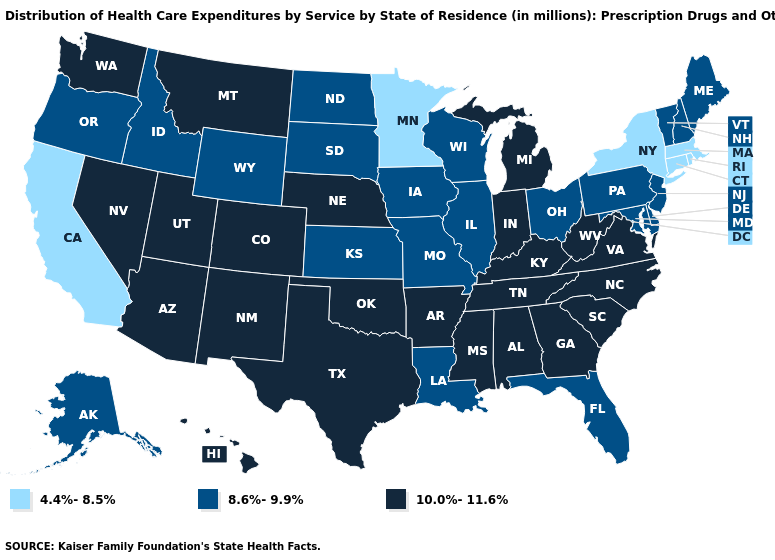What is the value of Alaska?
Keep it brief. 8.6%-9.9%. What is the value of Alaska?
Answer briefly. 8.6%-9.9%. What is the highest value in the USA?
Write a very short answer. 10.0%-11.6%. How many symbols are there in the legend?
Answer briefly. 3. Among the states that border Massachusetts , which have the highest value?
Be succinct. New Hampshire, Vermont. Name the states that have a value in the range 8.6%-9.9%?
Answer briefly. Alaska, Delaware, Florida, Idaho, Illinois, Iowa, Kansas, Louisiana, Maine, Maryland, Missouri, New Hampshire, New Jersey, North Dakota, Ohio, Oregon, Pennsylvania, South Dakota, Vermont, Wisconsin, Wyoming. Which states hav the highest value in the MidWest?
Give a very brief answer. Indiana, Michigan, Nebraska. Name the states that have a value in the range 10.0%-11.6%?
Answer briefly. Alabama, Arizona, Arkansas, Colorado, Georgia, Hawaii, Indiana, Kentucky, Michigan, Mississippi, Montana, Nebraska, Nevada, New Mexico, North Carolina, Oklahoma, South Carolina, Tennessee, Texas, Utah, Virginia, Washington, West Virginia. Does Louisiana have the highest value in the South?
Be succinct. No. What is the highest value in states that border Iowa?
Concise answer only. 10.0%-11.6%. Does Minnesota have the lowest value in the USA?
Short answer required. Yes. Does Arkansas have a lower value than Montana?
Give a very brief answer. No. What is the value of Vermont?
Give a very brief answer. 8.6%-9.9%. Which states have the lowest value in the Northeast?
Keep it brief. Connecticut, Massachusetts, New York, Rhode Island. Does Idaho have the highest value in the West?
Short answer required. No. 